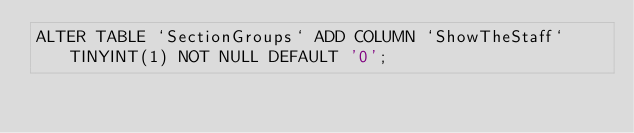Convert code to text. <code><loc_0><loc_0><loc_500><loc_500><_SQL_>ALTER TABLE `SectionGroups` ADD COLUMN `ShowTheStaff` TINYINT(1) NOT NULL DEFAULT '0';
</code> 